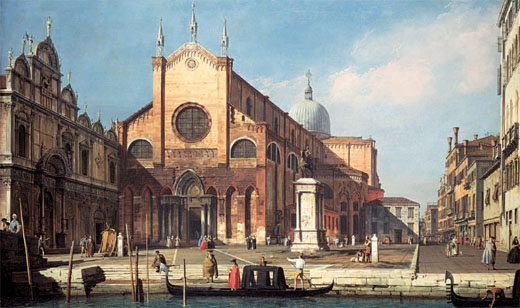If this church could tell a story, what would it be? If this Gothic church could tell a story, it would narrate tales of centuries gone by. It would speak of its inception during a grand era of architectural triumph. The church would recount the countless prayers whispered within its walls, the joyous celebrations of weddings, and the somber moments of farewells. It would talk about witnessing the rise and fall of empires, the evolution of the city’s bustling life, and the relentless flow of history around its steadfast form. Most importantly, it would share the stories of the people - the artisans who crafted it, the faithful who frequented it, and the generations that have passed under its watchful gaze. 